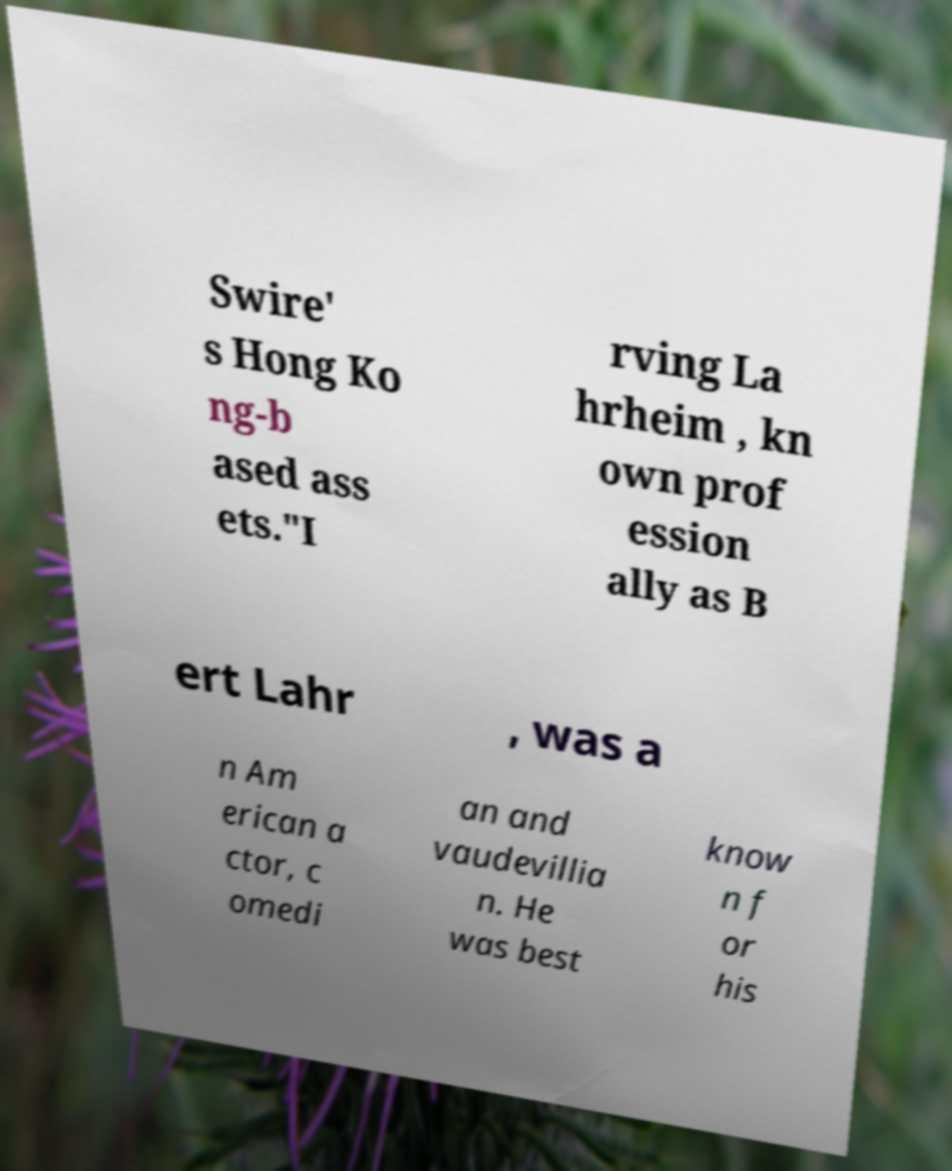Please read and relay the text visible in this image. What does it say? Swire' s Hong Ko ng-b ased ass ets."I rving La hrheim , kn own prof ession ally as B ert Lahr , was a n Am erican a ctor, c omedi an and vaudevillia n. He was best know n f or his 